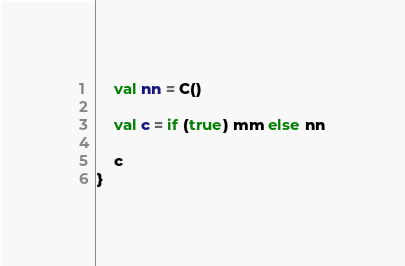Convert code to text. <code><loc_0><loc_0><loc_500><loc_500><_Kotlin_>    val nn = C()

    val c = if (true) mm else nn

    c
}
</code> 